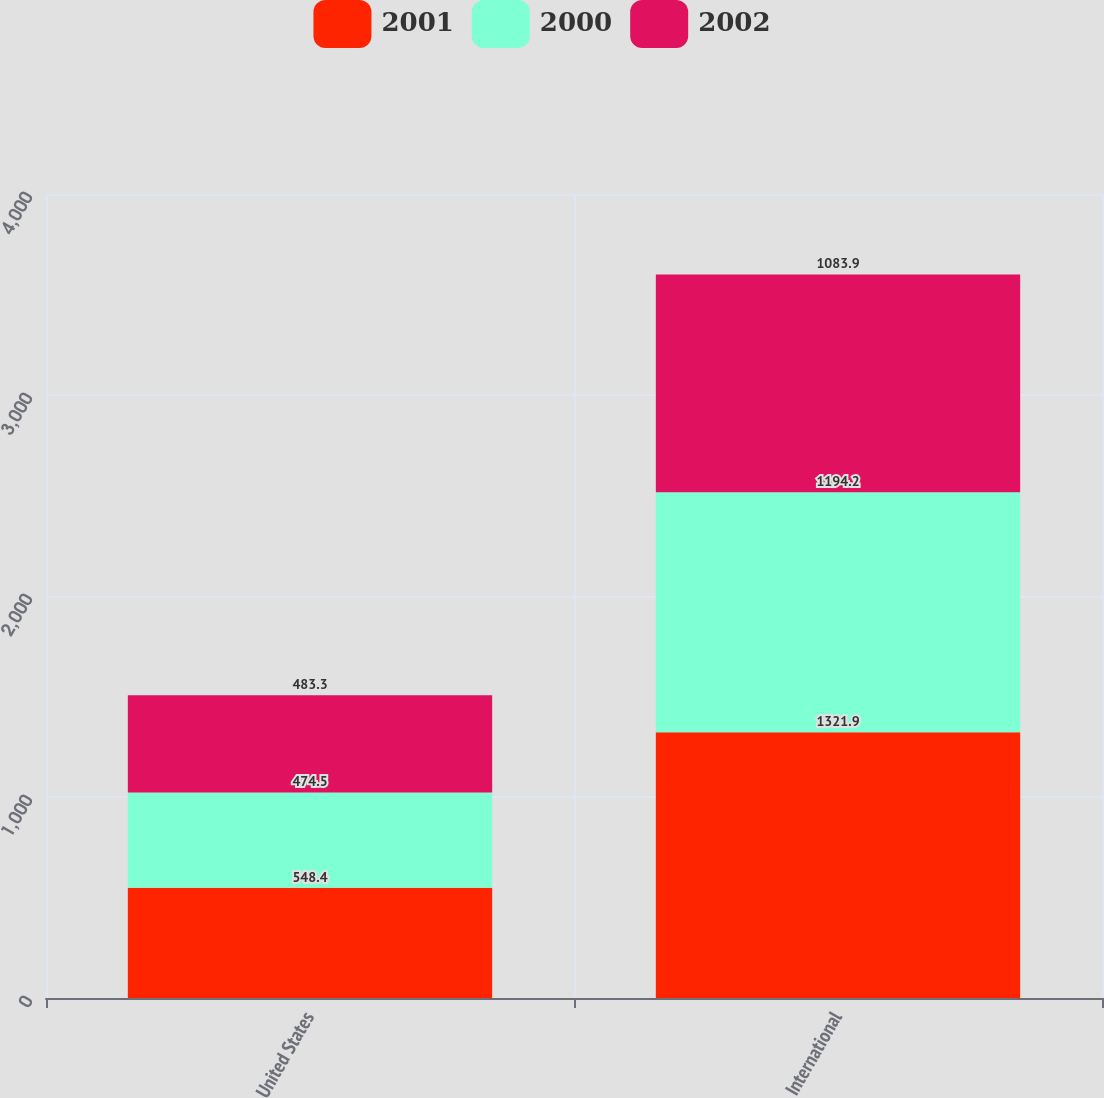Convert chart. <chart><loc_0><loc_0><loc_500><loc_500><stacked_bar_chart><ecel><fcel>United States<fcel>International<nl><fcel>2001<fcel>548.4<fcel>1321.9<nl><fcel>2000<fcel>474.5<fcel>1194.2<nl><fcel>2002<fcel>483.3<fcel>1083.9<nl></chart> 